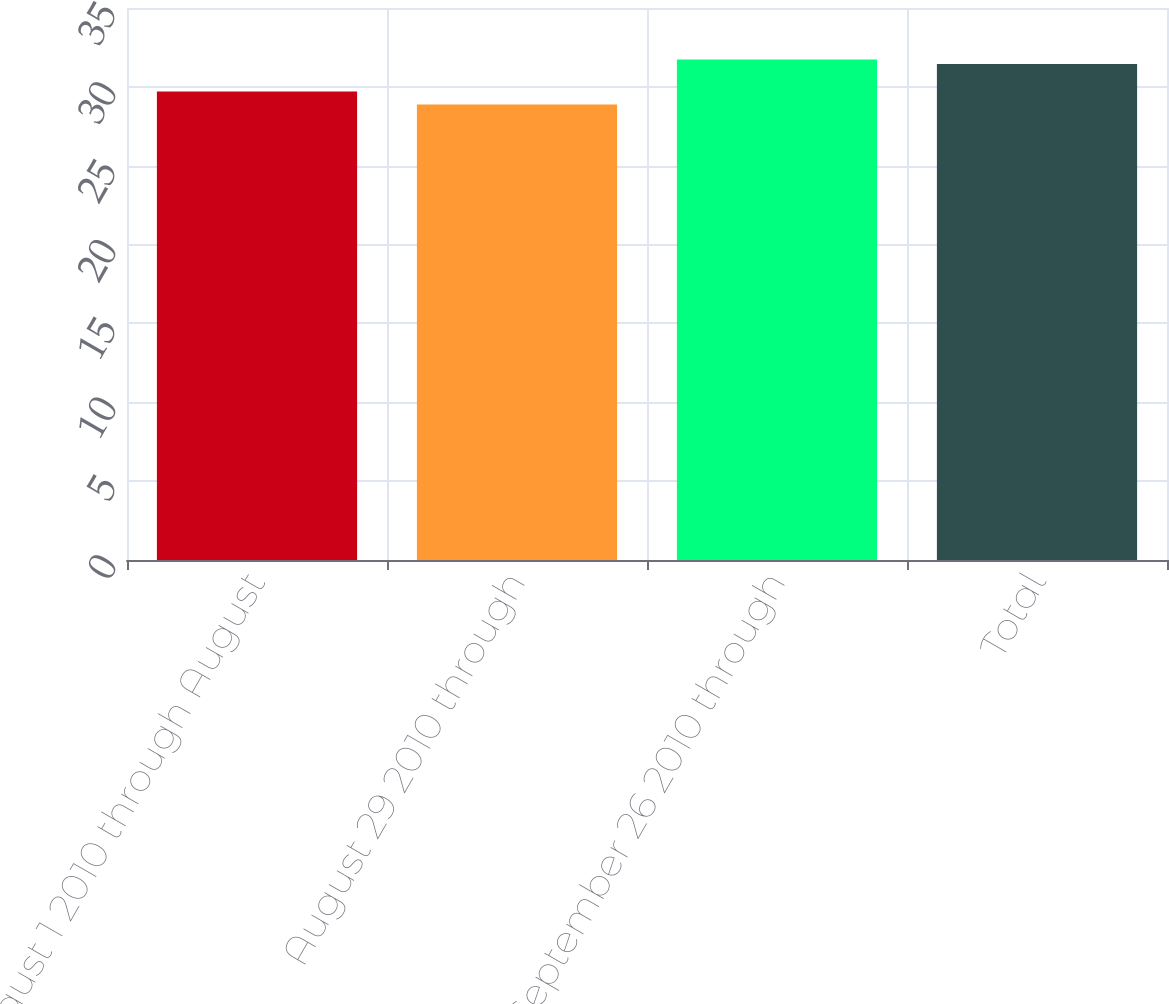<chart> <loc_0><loc_0><loc_500><loc_500><bar_chart><fcel>August 1 2010 through August<fcel>August 29 2010 through<fcel>September 26 2010 through<fcel>Total<nl><fcel>29.7<fcel>28.88<fcel>31.73<fcel>31.45<nl></chart> 